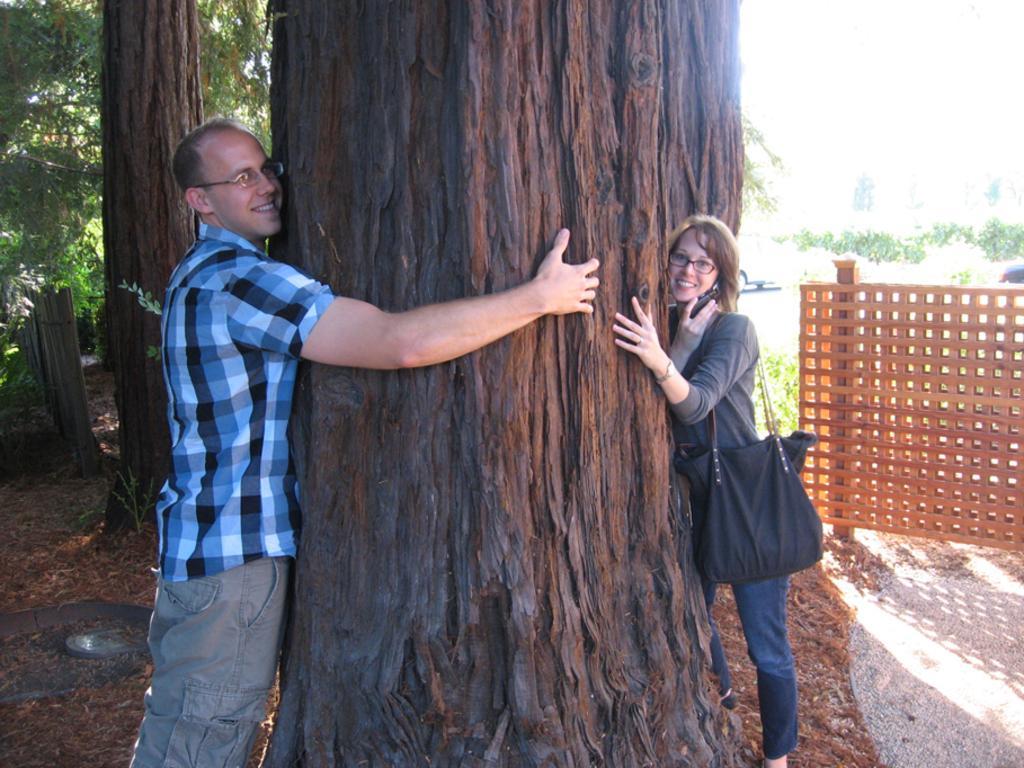Could you give a brief overview of what you see in this image? The person wearing grey pant is hugging the tree and the women wearing the grey shirt is hugging the tree with one hand and holding a phone on her other hand and also carrying a black hand bag. 